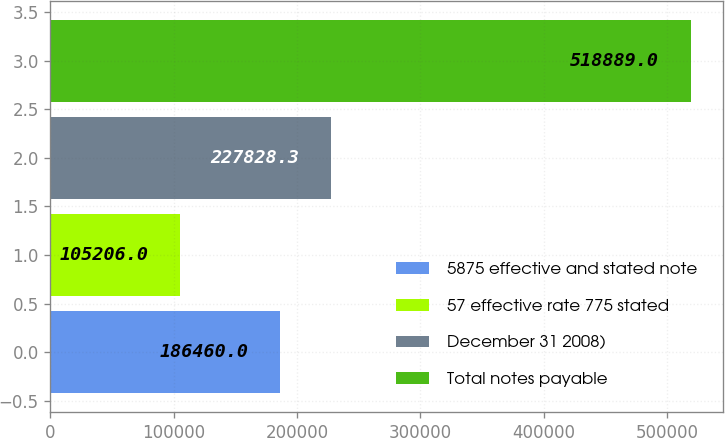Convert chart. <chart><loc_0><loc_0><loc_500><loc_500><bar_chart><fcel>5875 effective and stated note<fcel>57 effective rate 775 stated<fcel>December 31 2008)<fcel>Total notes payable<nl><fcel>186460<fcel>105206<fcel>227828<fcel>518889<nl></chart> 